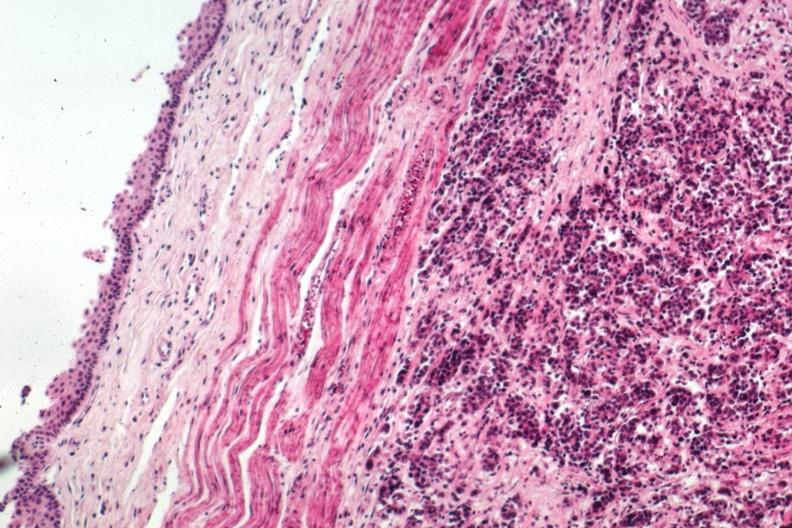s gastrointestinal present?
Answer the question using a single word or phrase. Yes 